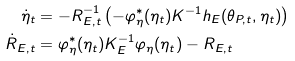<formula> <loc_0><loc_0><loc_500><loc_500>\dot { \eta } _ { t } & = - R ^ { - 1 } _ { E , t } \left ( - \varphi ^ { * } _ { \eta } ( \eta _ { t } ) K ^ { - 1 } h _ { E } ( \theta _ { P , t } , \eta _ { t } ) \right ) \\ \dot { R } _ { E , t } & = \varphi ^ { * } _ { \eta } ( \eta _ { t } ) K _ { E } ^ { - 1 } \varphi _ { \eta } ( \eta _ { t } ) - R _ { E , t }</formula> 